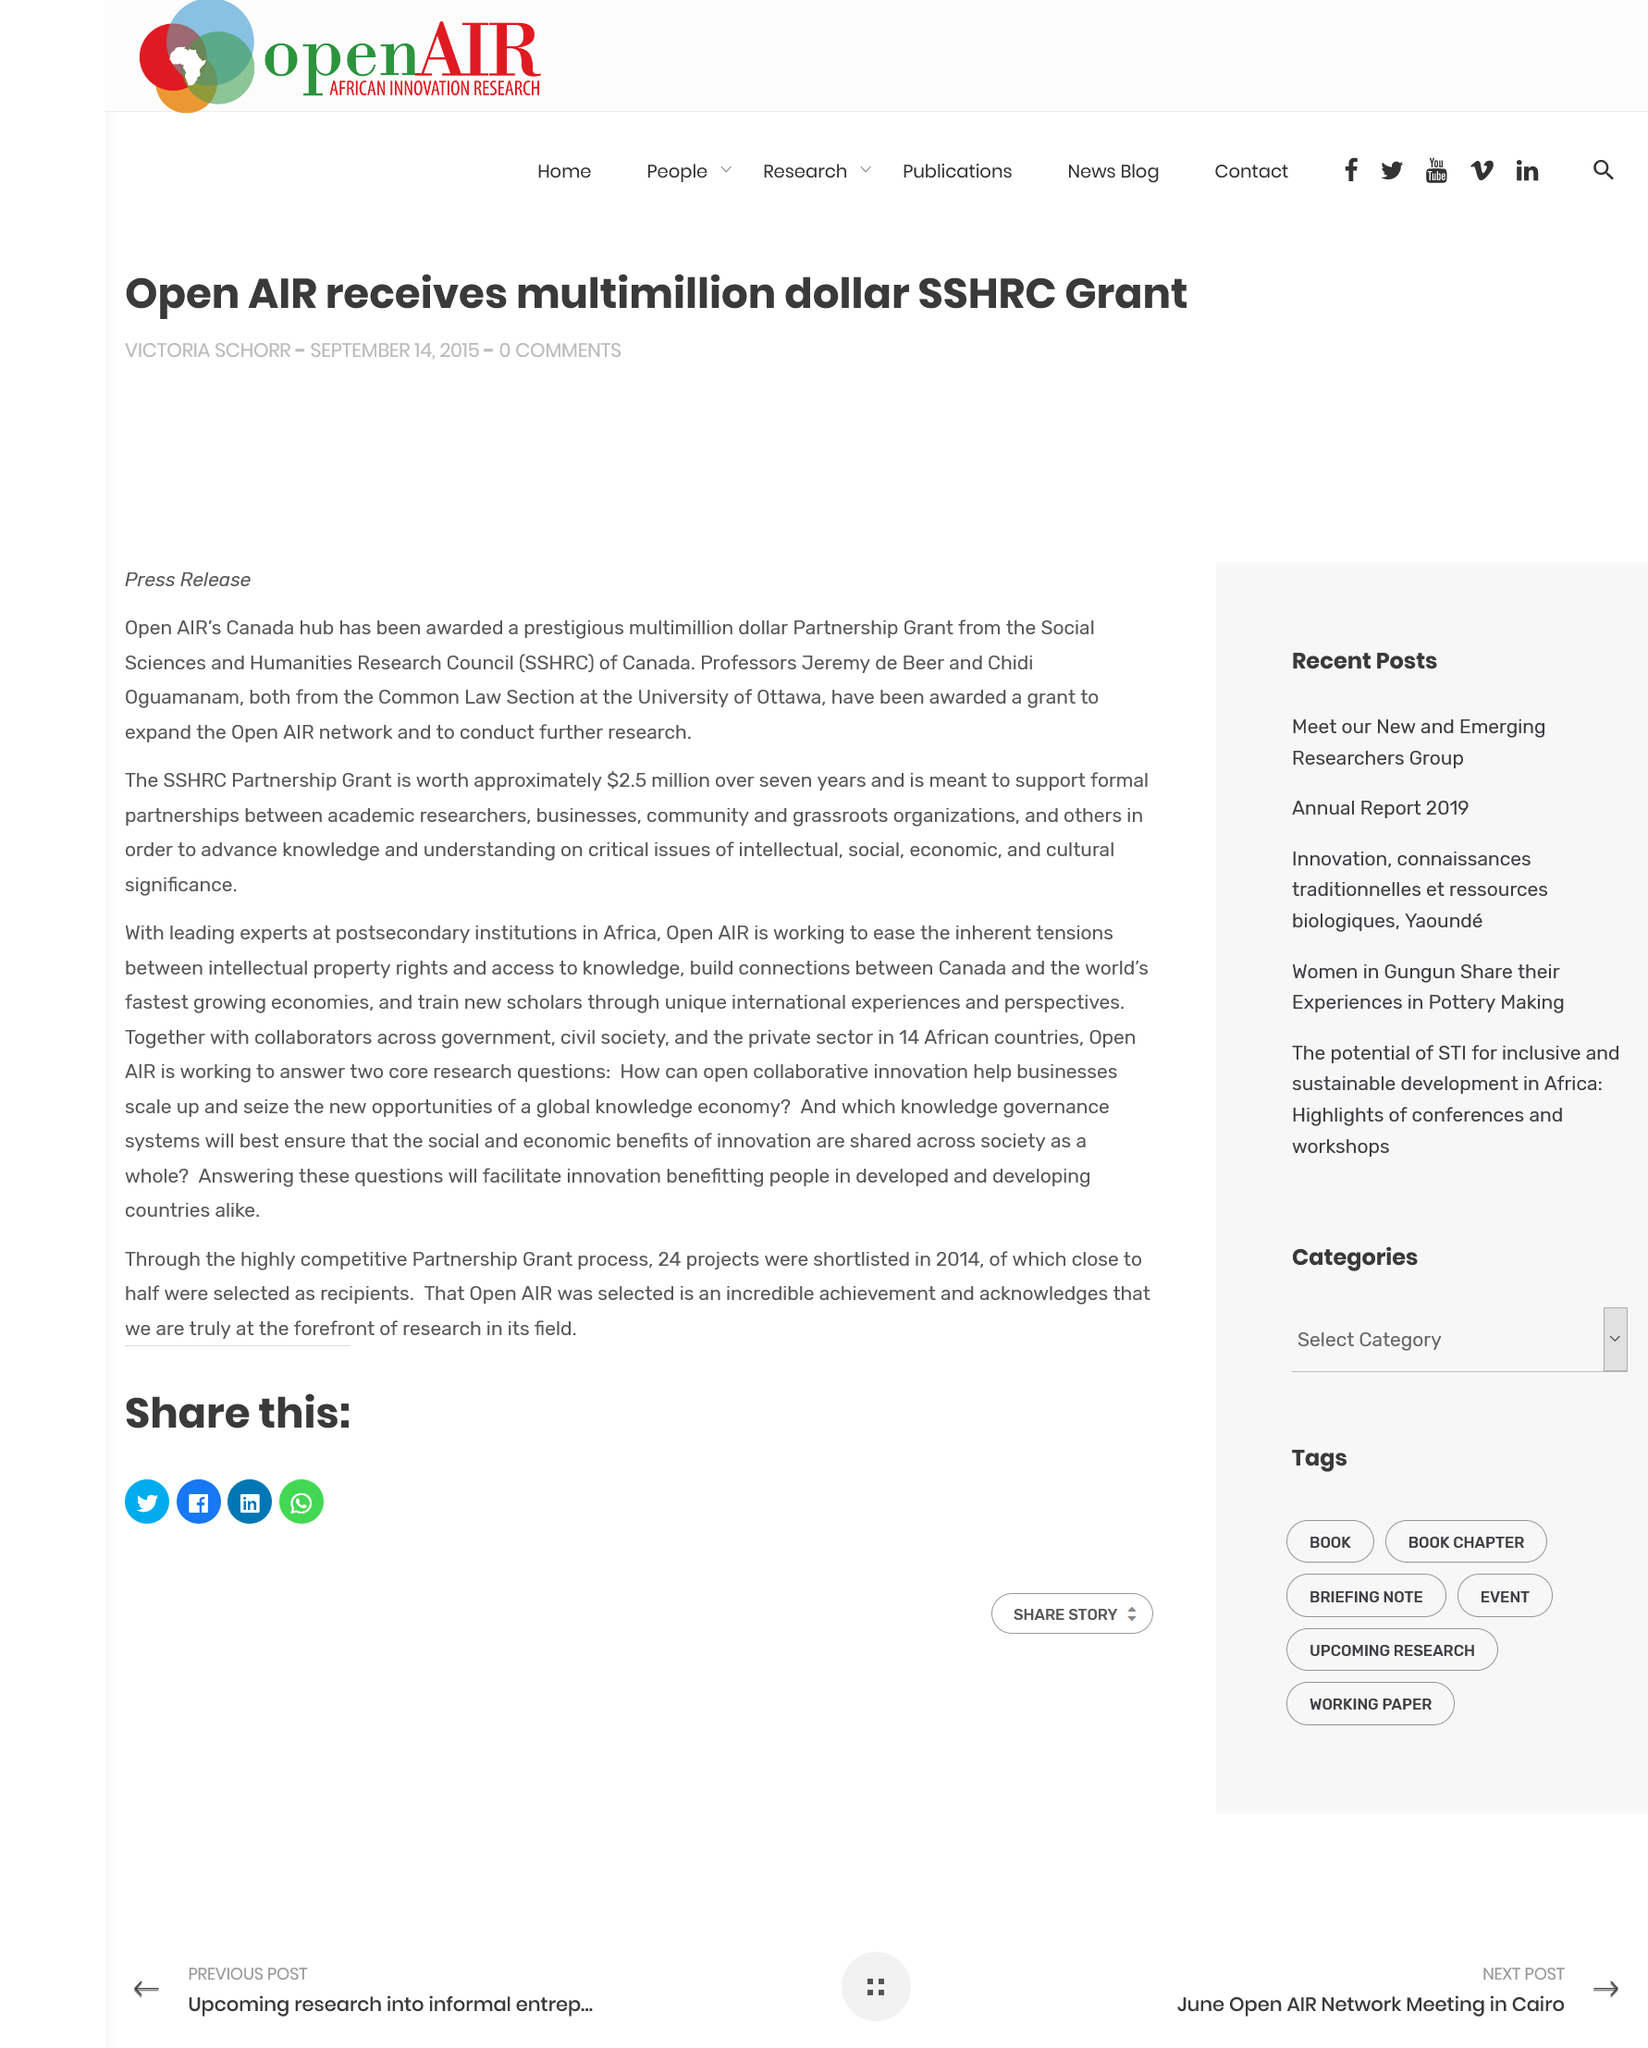Highlight a few significant elements in this photo. The author's name is Victoria Schorr. The publication date is September 14, 2015. Open AIR's Canada hub has been awarded a prestigious multimillion dollar Partnership Grand from the Social Sciences and Humanities Research Council, recognizing our outstanding contributions to the field of digital research. 